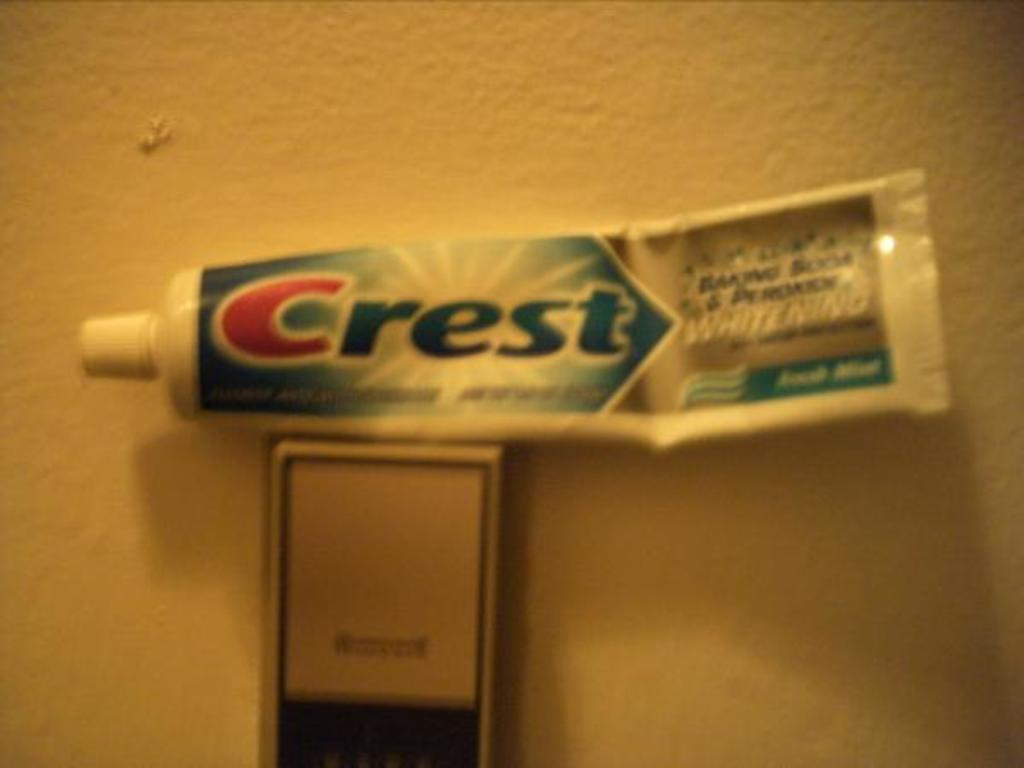<image>
Present a compact description of the photo's key features. A tube of opened Crest toothpaste that whitens people's teeth. 